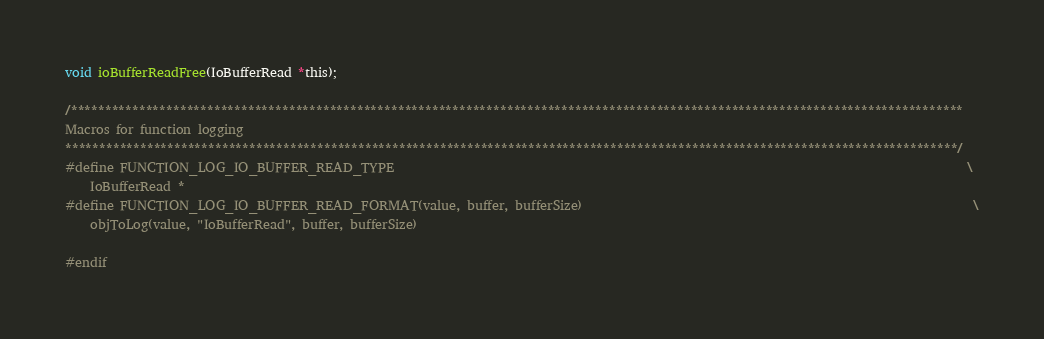Convert code to text. <code><loc_0><loc_0><loc_500><loc_500><_C_>void ioBufferReadFree(IoBufferRead *this);

/***********************************************************************************************************************************
Macros for function logging
***********************************************************************************************************************************/
#define FUNCTION_LOG_IO_BUFFER_READ_TYPE                                                                                           \
    IoBufferRead *
#define FUNCTION_LOG_IO_BUFFER_READ_FORMAT(value, buffer, bufferSize)                                                              \
    objToLog(value, "IoBufferRead", buffer, bufferSize)

#endif
</code> 